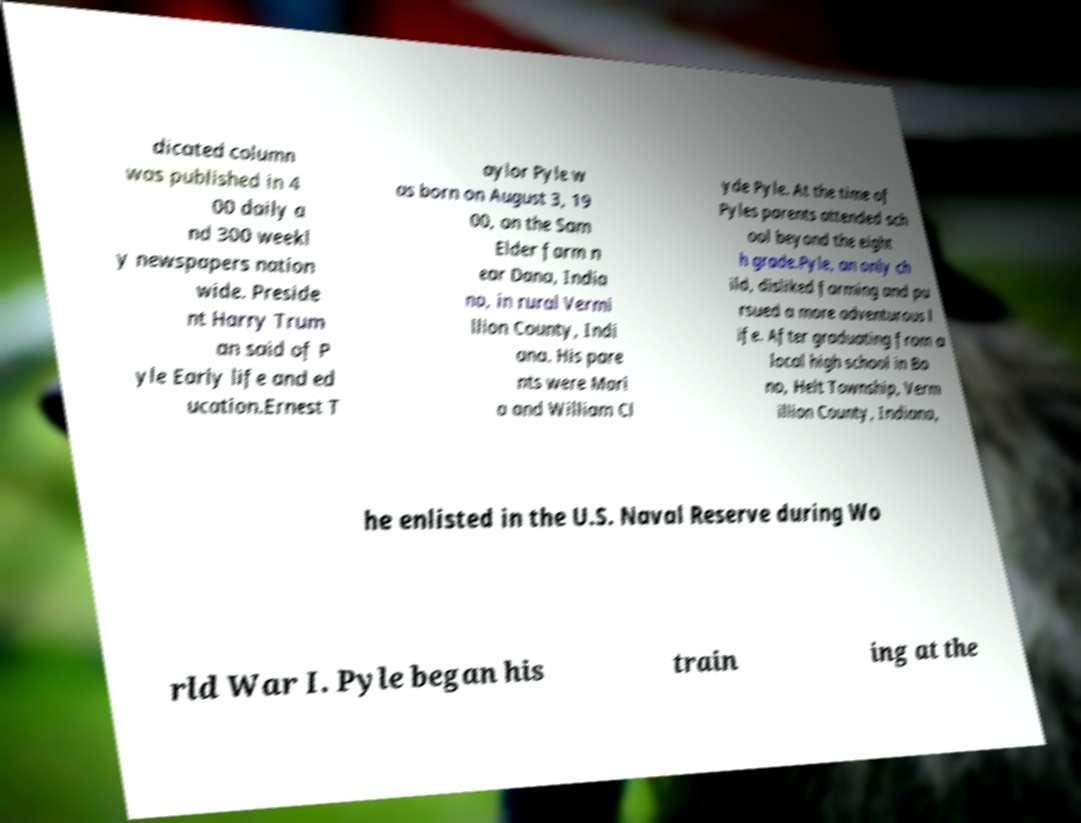Could you extract and type out the text from this image? dicated column was published in 4 00 daily a nd 300 weekl y newspapers nation wide. Preside nt Harry Trum an said of P yle Early life and ed ucation.Ernest T aylor Pyle w as born on August 3, 19 00, on the Sam Elder farm n ear Dana, India na, in rural Vermi llion County, Indi ana. His pare nts were Mari a and William Cl yde Pyle. At the time of Pyles parents attended sch ool beyond the eight h grade.Pyle, an only ch ild, disliked farming and pu rsued a more adventurous l ife. After graduating from a local high school in Bo no, Helt Township, Verm illion County, Indiana, he enlisted in the U.S. Naval Reserve during Wo rld War I. Pyle began his train ing at the 